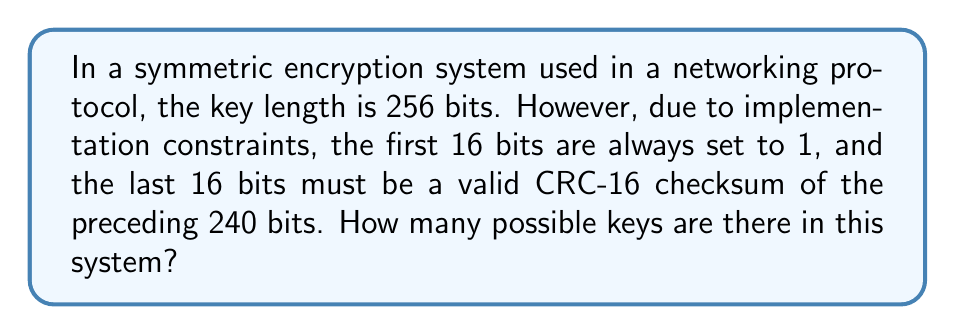Teach me how to tackle this problem. Let's approach this step-by-step:

1) The total key length is 256 bits.

2) The first 16 bits are fixed (always set to 1), so they don't contribute to the number of possible keys.

3) The last 16 bits are determined by the CRC-16 checksum of the preceding 240 bits, so they also don't contribute to the number of possible keys.

4) This leaves us with 256 - 16 - 16 = 224 bits that can be freely chosen.

5) In a binary system, each bit can be either 0 or 1, giving 2 possibilities per bit.

6) For 224 independently choosable bits, the total number of possibilities is:

   $$2^{224}$$

7) This can be expressed as:

   $$2^{224} = 2^{8 \times 28} = (2^8)^{28} = 256^{28}$$

Therefore, the number of possible keys in this system is $256^{28}$.
Answer: $256^{28}$ 